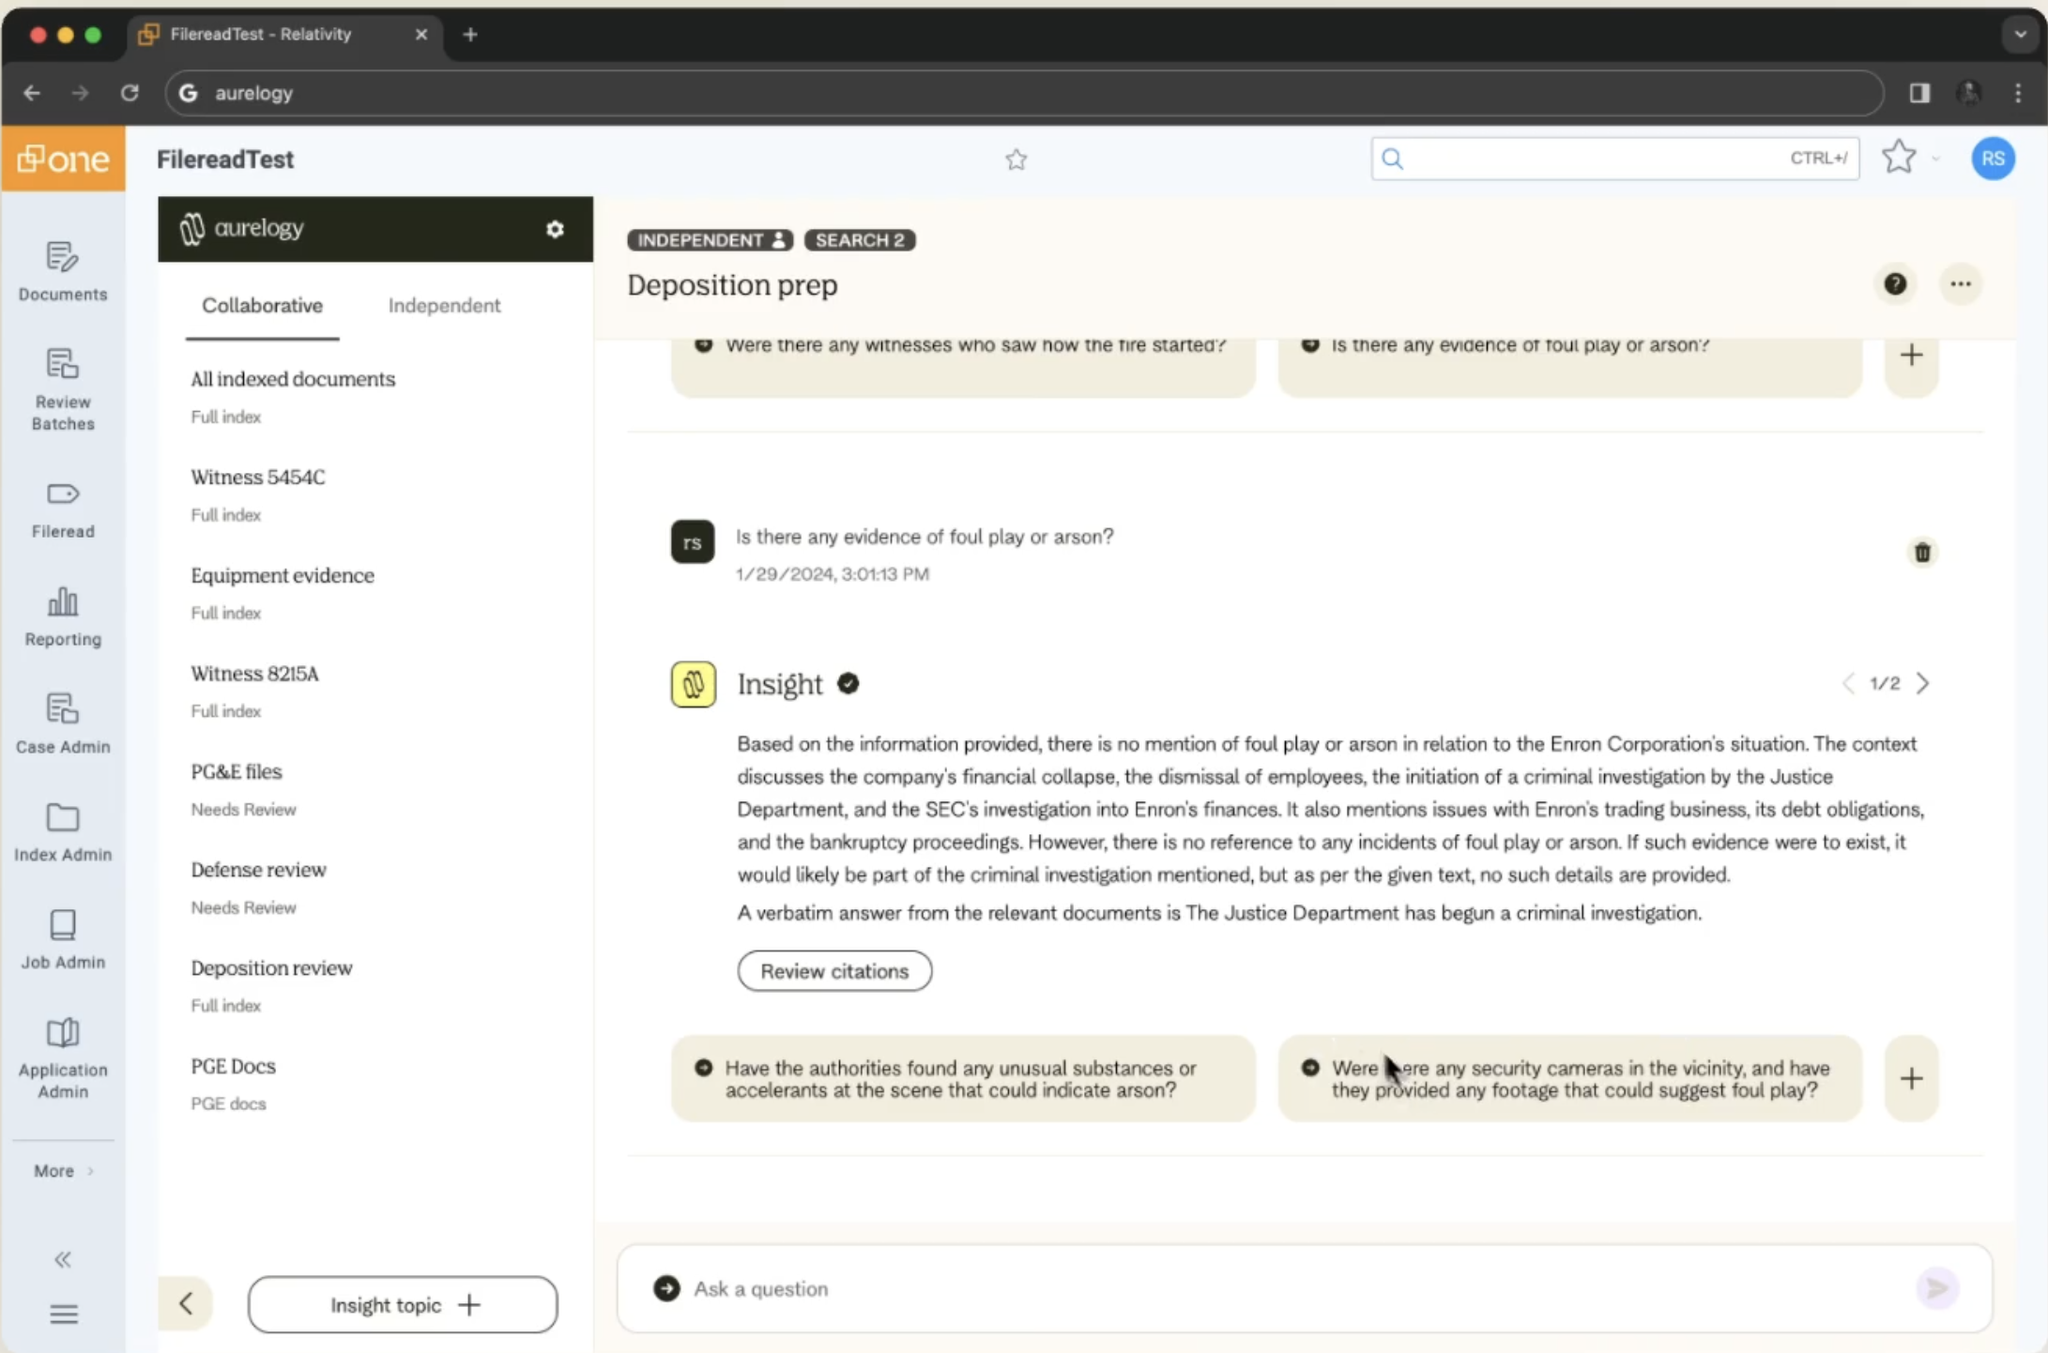what is this image?
 This image shows a screenshot of a software interface called "Relativity", which appears to be a document review and analysis platform used for legal purposes. The interface is displaying a section labeled "FilereadTest" and includes several key elements:

1. A sidebar on the left listing different document categories and review options.
2. A main content area showing a "Deposition prep" section with multiple questions related to an investigation.
3. An "Insight" panel providing an AI-generated response to one of the questions, specifically addressing whether there's evidence of foul play or arson in relation to the Enron Corporation's situation.

The interface seems designed for legal professionals to organize, review, and analyze documents and information related to a case or investigation. The specific content visible relates to the Enron Corporation's financial collapse and subsequent investigations, mentioning the Justice Department's criminal investigation and the SEC's involvement. 